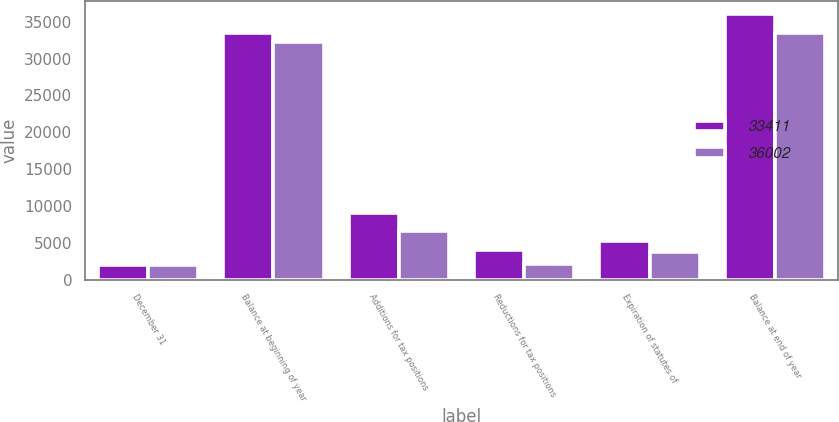Convert chart to OTSL. <chart><loc_0><loc_0><loc_500><loc_500><stacked_bar_chart><ecel><fcel>December 31<fcel>Balance at beginning of year<fcel>Additions for tax positions<fcel>Reductions for tax positions<fcel>Expiration of statutes of<fcel>Balance at end of year<nl><fcel>33411<fcel>2016<fcel>33411<fcel>9100<fcel>4080<fcel>5233<fcel>36002<nl><fcel>36002<fcel>2015<fcel>32230<fcel>6623<fcel>2112<fcel>3750<fcel>33411<nl></chart> 